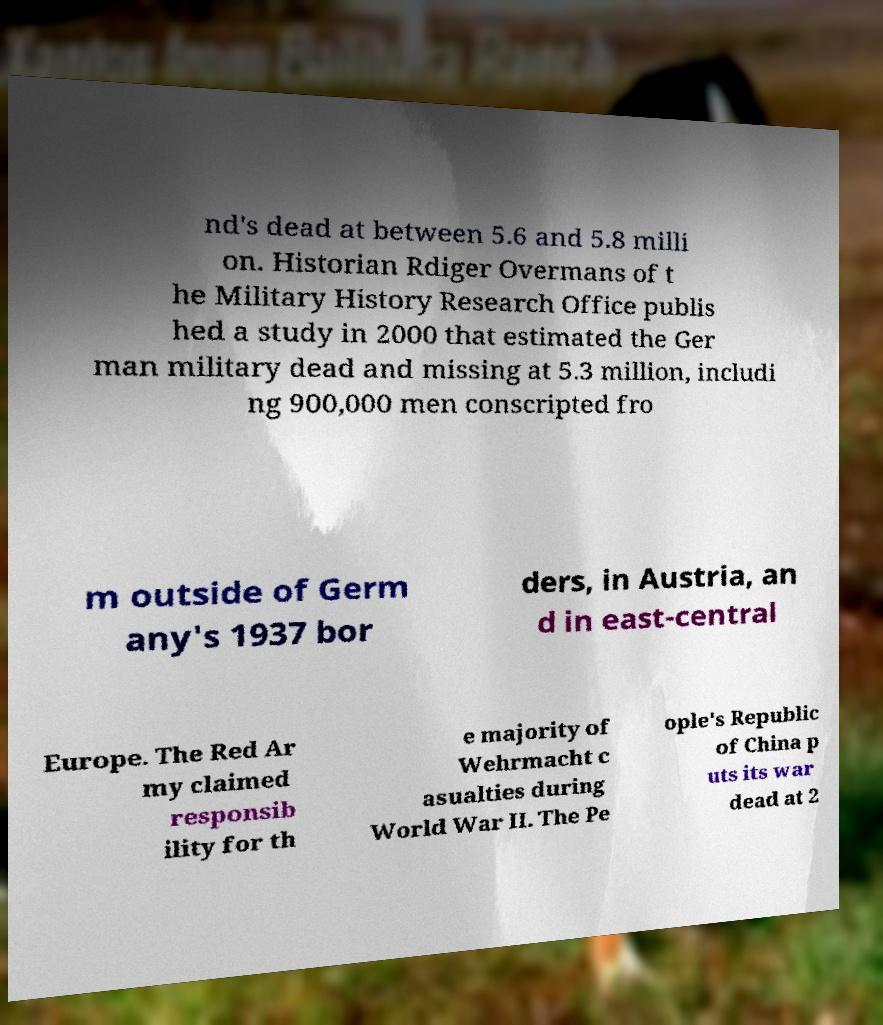Can you read and provide the text displayed in the image?This photo seems to have some interesting text. Can you extract and type it out for me? nd's dead at between 5.6 and 5.8 milli on. Historian Rdiger Overmans of t he Military History Research Office publis hed a study in 2000 that estimated the Ger man military dead and missing at 5.3 million, includi ng 900,000 men conscripted fro m outside of Germ any's 1937 bor ders, in Austria, an d in east-central Europe. The Red Ar my claimed responsib ility for th e majority of Wehrmacht c asualties during World War II. The Pe ople's Republic of China p uts its war dead at 2 